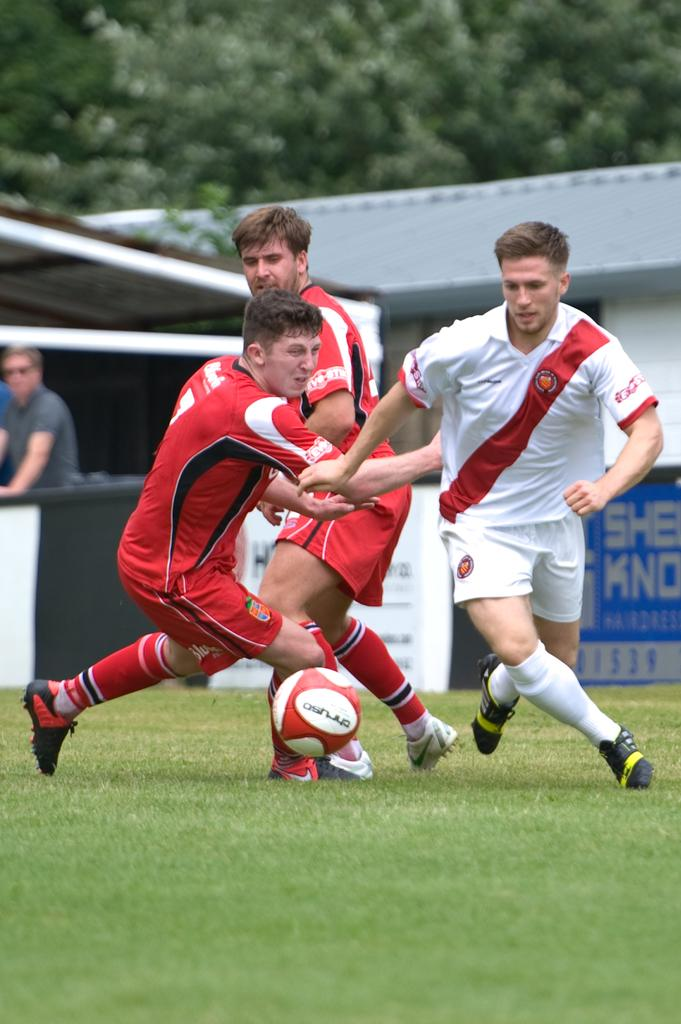How many men are present in the image? There are three men in the image. What are the men doing in the image? The men are on the grass. What object is related to a sport that can be seen in the image? There is a football in the image. Can you describe the background of the image? There is another person, a shed, and trees in the background of the image. What type of rifle can be seen in the hands of one of the men in the image? There is no rifle present in the image; the men are not holding any weapons. How many kittens are playing with the football in the image? There are no kittens present in the image; the football is not being played with by any animals. 